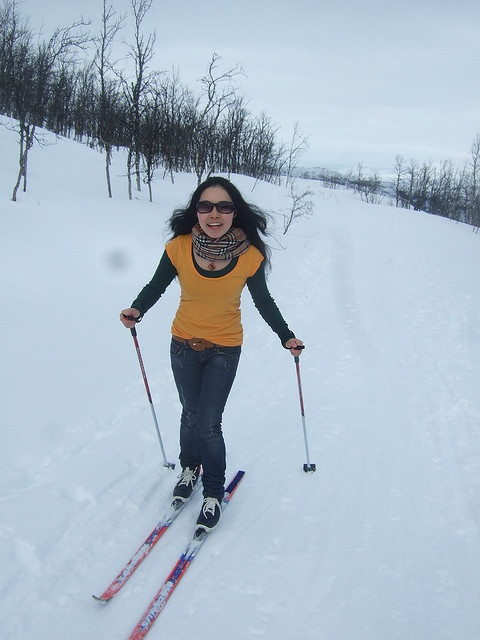Describe the objects in this image and their specific colors. I can see people in darkgray, black, olive, and gray tones and skis in darkgray, lightblue, and brown tones in this image. 